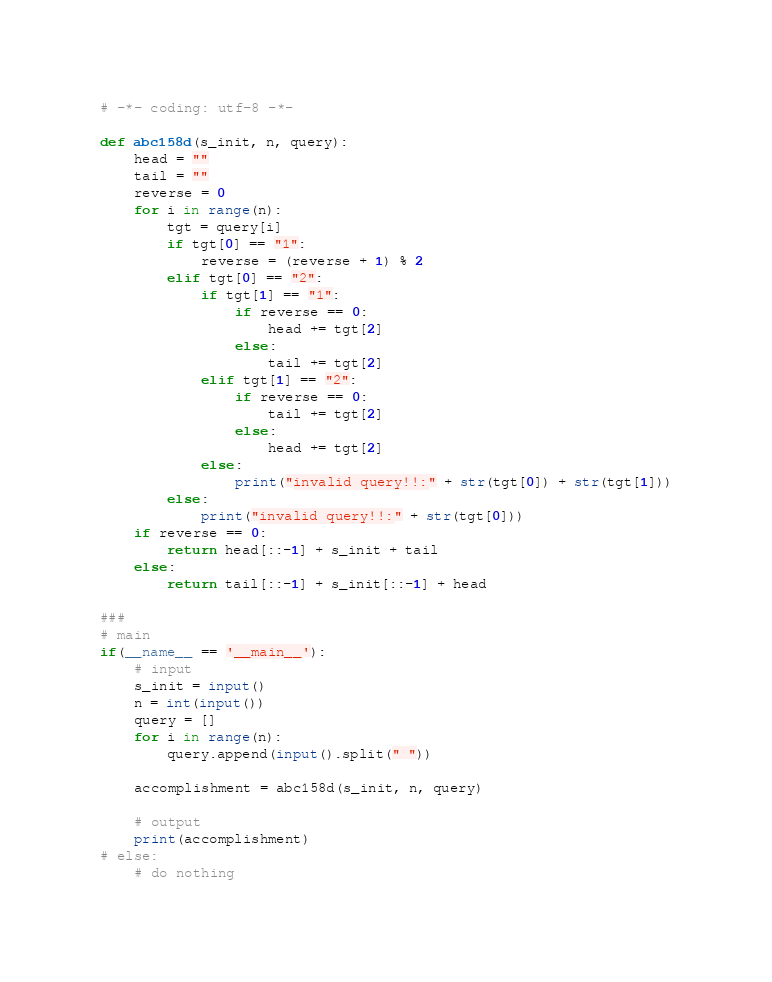<code> <loc_0><loc_0><loc_500><loc_500><_Python_># -*- coding: utf-8 -*-

def abc158d(s_init, n, query):
    head = ""
    tail = ""
    reverse = 0
    for i in range(n):
        tgt = query[i]
        if tgt[0] == "1":
            reverse = (reverse + 1) % 2
        elif tgt[0] == "2":
            if tgt[1] == "1":
                if reverse == 0:
                    head += tgt[2]
                else:
                    tail += tgt[2]
            elif tgt[1] == "2":
                if reverse == 0:
                    tail += tgt[2]
                else:
                    head += tgt[2]
            else:
                print("invalid query!!:" + str(tgt[0]) + str(tgt[1]))
        else:
            print("invalid query!!:" + str(tgt[0]))
    if reverse == 0:
        return head[::-1] + s_init + tail
    else:
        return tail[::-1] + s_init[::-1] + head

###
# main
if(__name__ == '__main__'):
    # input
    s_init = input()
    n = int(input())
    query = []
    for i in range(n):
        query.append(input().split(" "))
    
    accomplishment = abc158d(s_init, n, query)
    
    # output
    print(accomplishment)
# else:
    # do nothing
</code> 